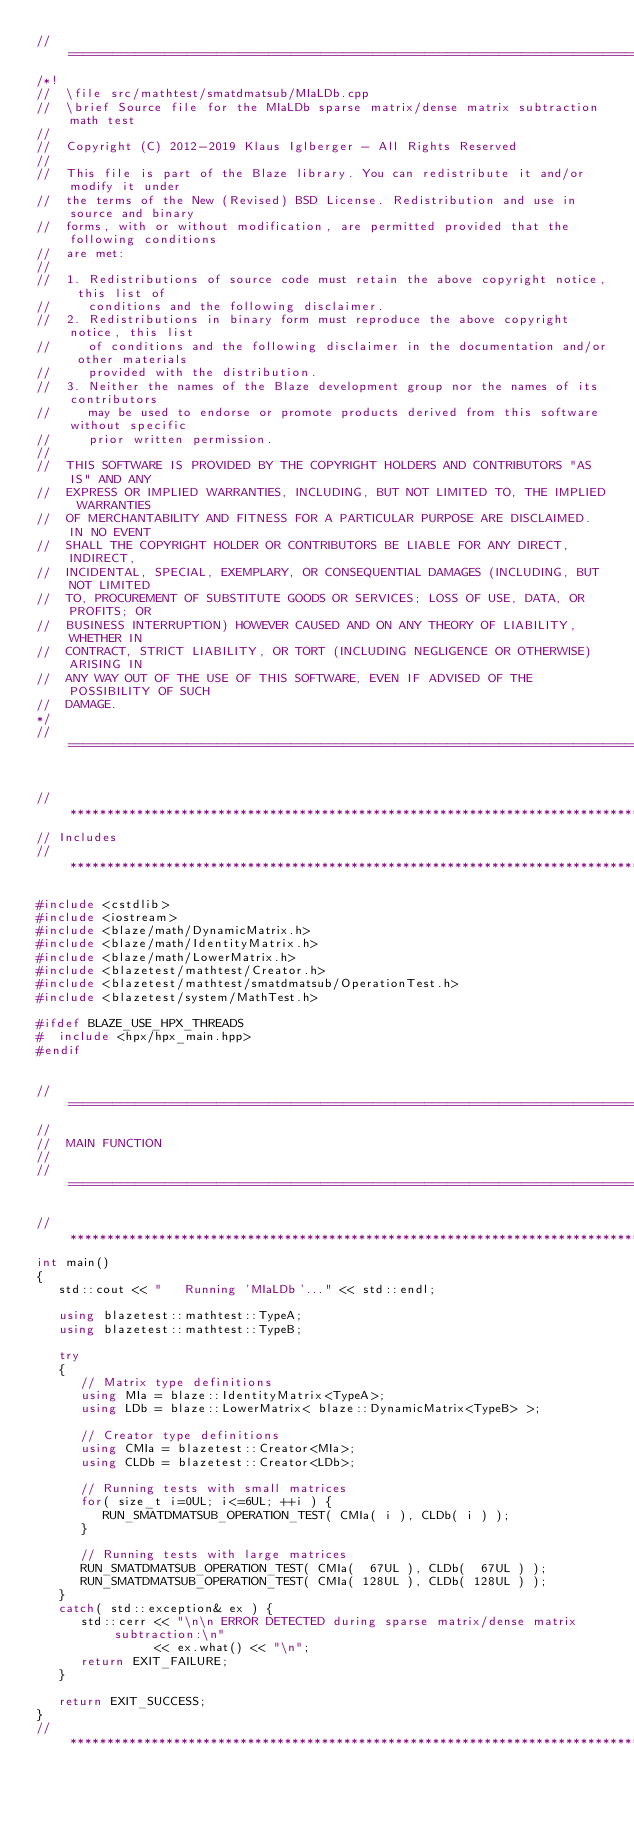<code> <loc_0><loc_0><loc_500><loc_500><_C++_>//=================================================================================================
/*!
//  \file src/mathtest/smatdmatsub/MIaLDb.cpp
//  \brief Source file for the MIaLDb sparse matrix/dense matrix subtraction math test
//
//  Copyright (C) 2012-2019 Klaus Iglberger - All Rights Reserved
//
//  This file is part of the Blaze library. You can redistribute it and/or modify it under
//  the terms of the New (Revised) BSD License. Redistribution and use in source and binary
//  forms, with or without modification, are permitted provided that the following conditions
//  are met:
//
//  1. Redistributions of source code must retain the above copyright notice, this list of
//     conditions and the following disclaimer.
//  2. Redistributions in binary form must reproduce the above copyright notice, this list
//     of conditions and the following disclaimer in the documentation and/or other materials
//     provided with the distribution.
//  3. Neither the names of the Blaze development group nor the names of its contributors
//     may be used to endorse or promote products derived from this software without specific
//     prior written permission.
//
//  THIS SOFTWARE IS PROVIDED BY THE COPYRIGHT HOLDERS AND CONTRIBUTORS "AS IS" AND ANY
//  EXPRESS OR IMPLIED WARRANTIES, INCLUDING, BUT NOT LIMITED TO, THE IMPLIED WARRANTIES
//  OF MERCHANTABILITY AND FITNESS FOR A PARTICULAR PURPOSE ARE DISCLAIMED. IN NO EVENT
//  SHALL THE COPYRIGHT HOLDER OR CONTRIBUTORS BE LIABLE FOR ANY DIRECT, INDIRECT,
//  INCIDENTAL, SPECIAL, EXEMPLARY, OR CONSEQUENTIAL DAMAGES (INCLUDING, BUT NOT LIMITED
//  TO, PROCUREMENT OF SUBSTITUTE GOODS OR SERVICES; LOSS OF USE, DATA, OR PROFITS; OR
//  BUSINESS INTERRUPTION) HOWEVER CAUSED AND ON ANY THEORY OF LIABILITY, WHETHER IN
//  CONTRACT, STRICT LIABILITY, OR TORT (INCLUDING NEGLIGENCE OR OTHERWISE) ARISING IN
//  ANY WAY OUT OF THE USE OF THIS SOFTWARE, EVEN IF ADVISED OF THE POSSIBILITY OF SUCH
//  DAMAGE.
*/
//=================================================================================================


//*************************************************************************************************
// Includes
//*************************************************************************************************

#include <cstdlib>
#include <iostream>
#include <blaze/math/DynamicMatrix.h>
#include <blaze/math/IdentityMatrix.h>
#include <blaze/math/LowerMatrix.h>
#include <blazetest/mathtest/Creator.h>
#include <blazetest/mathtest/smatdmatsub/OperationTest.h>
#include <blazetest/system/MathTest.h>

#ifdef BLAZE_USE_HPX_THREADS
#  include <hpx/hpx_main.hpp>
#endif


//=================================================================================================
//
//  MAIN FUNCTION
//
//=================================================================================================

//*************************************************************************************************
int main()
{
   std::cout << "   Running 'MIaLDb'..." << std::endl;

   using blazetest::mathtest::TypeA;
   using blazetest::mathtest::TypeB;

   try
   {
      // Matrix type definitions
      using MIa = blaze::IdentityMatrix<TypeA>;
      using LDb = blaze::LowerMatrix< blaze::DynamicMatrix<TypeB> >;

      // Creator type definitions
      using CMIa = blazetest::Creator<MIa>;
      using CLDb = blazetest::Creator<LDb>;

      // Running tests with small matrices
      for( size_t i=0UL; i<=6UL; ++i ) {
         RUN_SMATDMATSUB_OPERATION_TEST( CMIa( i ), CLDb( i ) );
      }

      // Running tests with large matrices
      RUN_SMATDMATSUB_OPERATION_TEST( CMIa(  67UL ), CLDb(  67UL ) );
      RUN_SMATDMATSUB_OPERATION_TEST( CMIa( 128UL ), CLDb( 128UL ) );
   }
   catch( std::exception& ex ) {
      std::cerr << "\n\n ERROR DETECTED during sparse matrix/dense matrix subtraction:\n"
                << ex.what() << "\n";
      return EXIT_FAILURE;
   }

   return EXIT_SUCCESS;
}
//*************************************************************************************************
</code> 